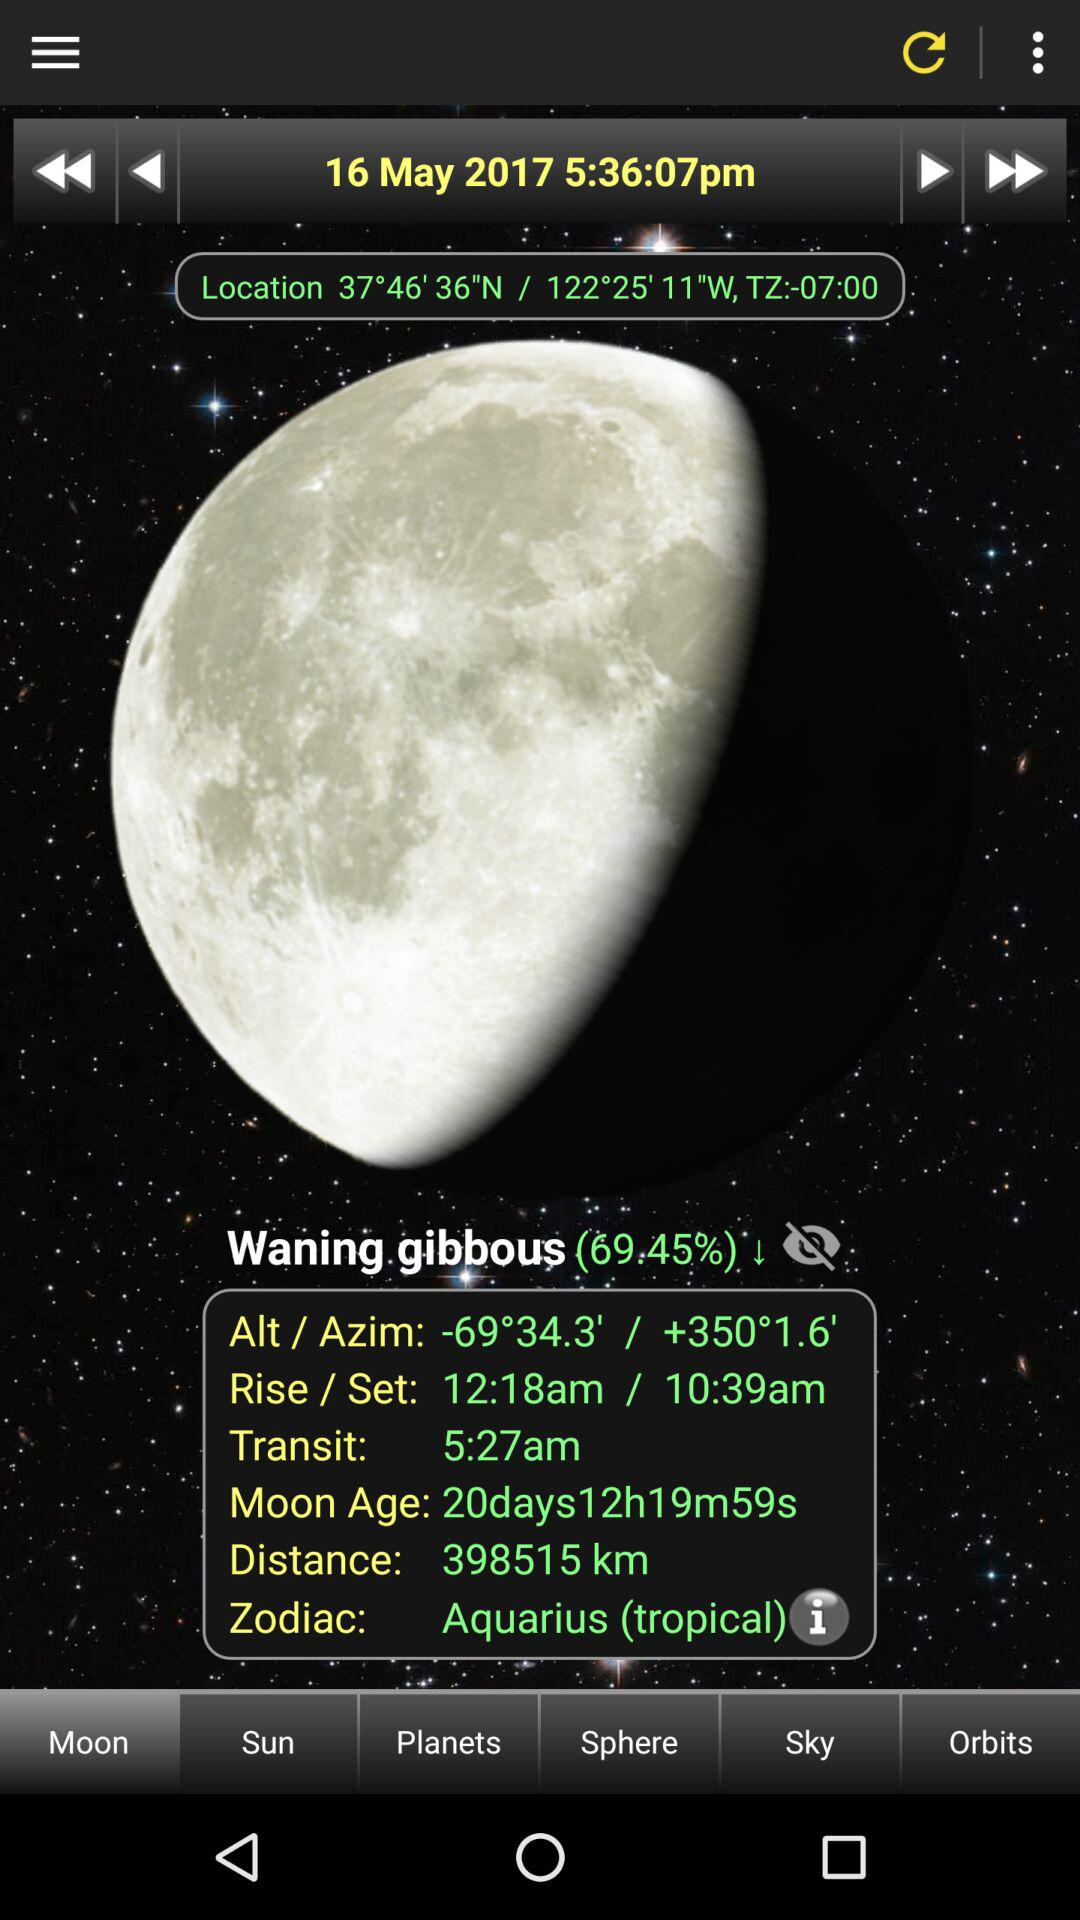What is the time? The time is 5:36:07 p.m. 